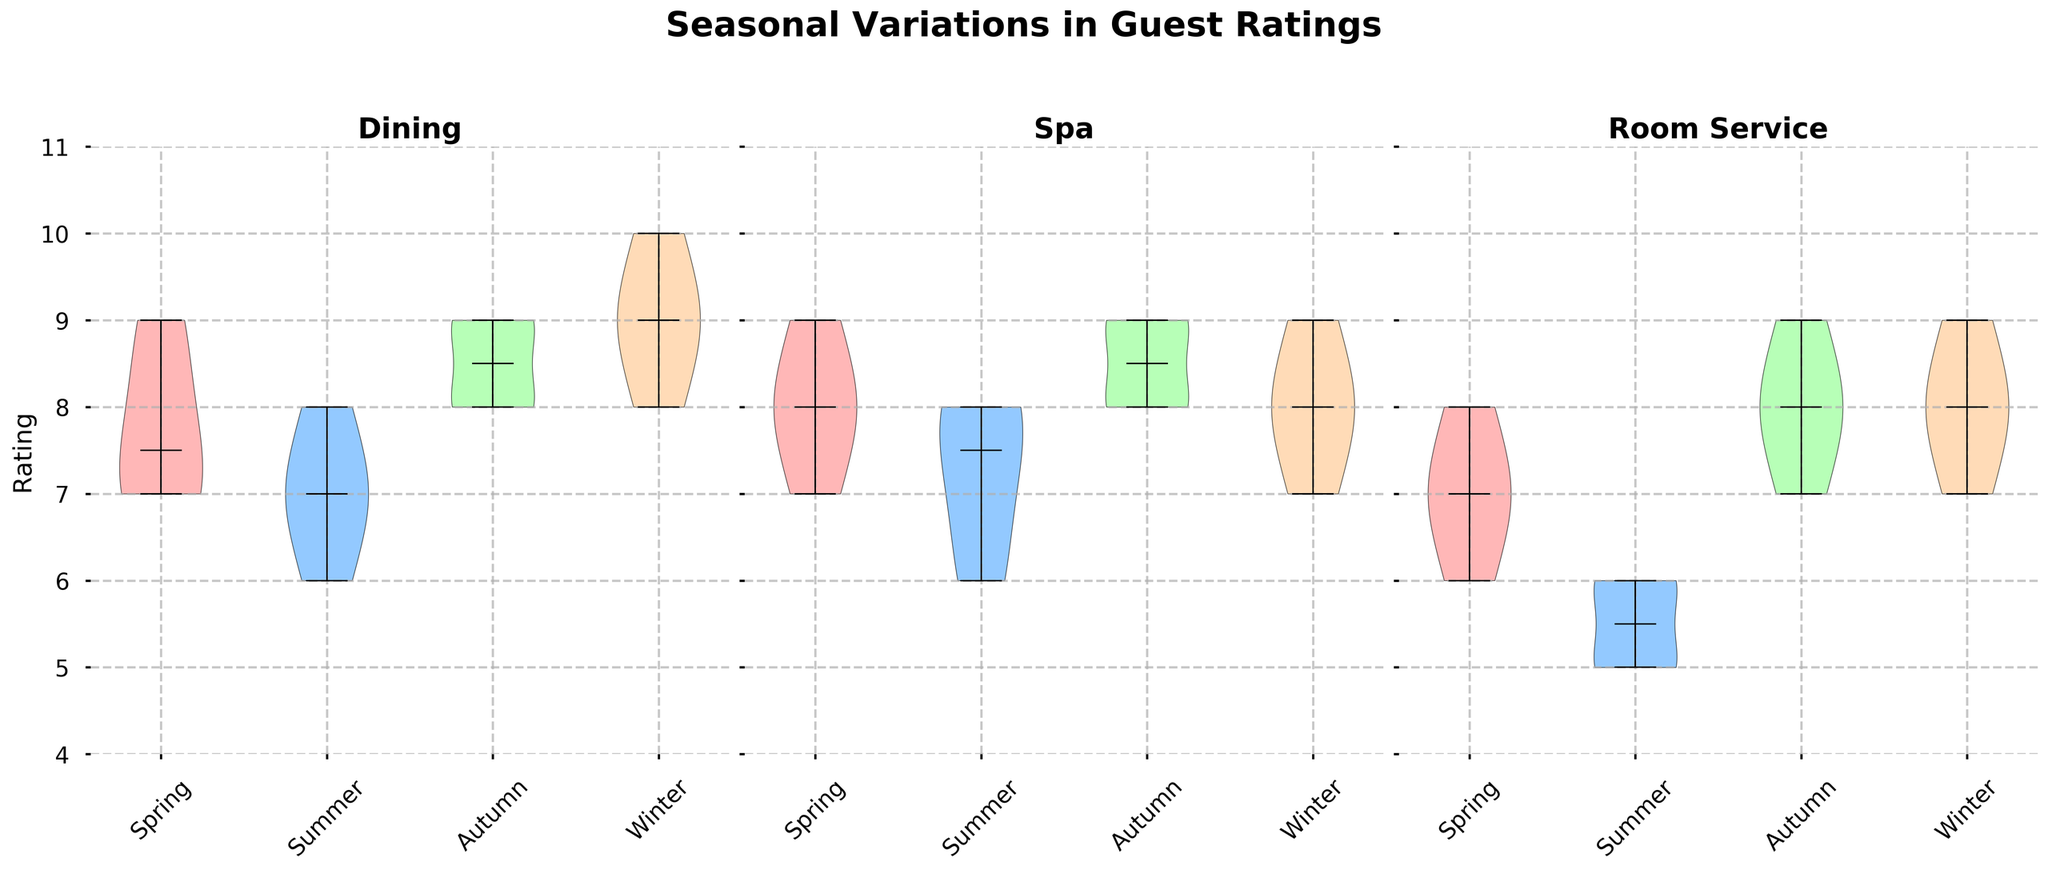What's the title of the figure? The title is usually placed at the top center of the figure and provides a concise description of what the figure represents. By looking at the top of the figure, the title "Seasonal Variations in Guest Ratings" is clearly visible.
Answer: Seasonal Variations in Guest Ratings Which season has the highest median rating for Dining? To find the highest median rating for Dining, look at the central line (median) of the violins for each season under the Dining category. The violin plot for Winter has the highest central line.
Answer: Winter Among the services, which one shows the most variability in guest ratings during Spring? Variability can be determined by the width and spread of the violin plots. For Spring, Spa shows a slightly wider spread compared to Dining and Room Service, indicating more variability.
Answer: Spa What is the range of guest ratings for Room Service in Summer? The range is found by identifying the highest and lowest points of the violin for Room Service in Summer. The highest point is 6 and the lowest is 5; therefore, the range is from 5 to 6.
Answer: 5 to 6 Which service is consistently rated highest across all seasons? To determine the consistently highest-rated service, compare the median lines (central lines) across all seasons for each service. Dining has the highest median ratings consistently across different seasons.
Answer: Dining How does the median rating of Spa in Autumn compare to the median rating of Spa in Spring? Compare the central lines in the violin plots for Spa in both Autumn and Spring. Both have a median rating very close, but at a closer look, Autumn has a slightly higher median than Spring.
Answer: Autumn is slightly higher Which season has the lowest minimum rating for Dining? The minimum rating is represented by the bottom point (lower whisker) of the violins. In Summer, the bottom point for Dining is the lowest compared to other seasons.
Answer: Summer Are the guest ratings for Room Service in Winter more positively skewed or negatively skewed? Skewness can be observed by the shape of the violin plot. A plot that bulges at the top is negatively skewed, while one that bulges at the bottom is positively skewed. For Winter, the Room Service violin bulges more at the top, indicating a negatively skewed distribution.
Answer: Negatively skewed Which season shows the widest range in ratings for Spa? The widest range can be found by comparing the top and bottom ends of the Spa violins for each season. In Winter, the range is widest from 7 to 9, compared to other seasons which are more clustered.
Answer: Winter 